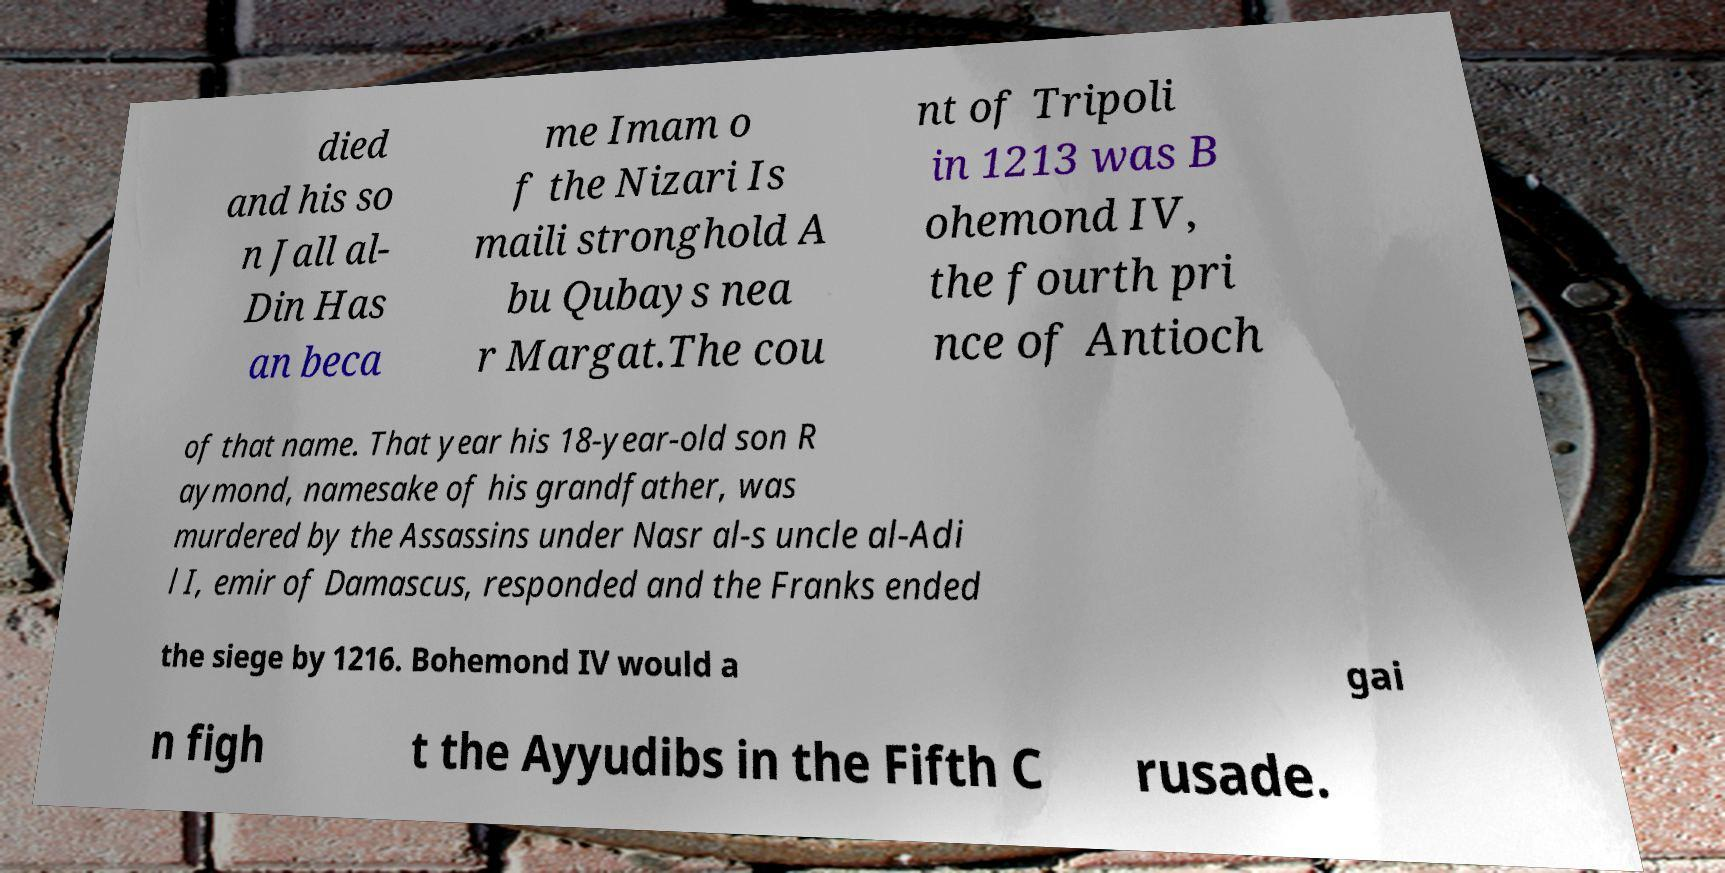Can you accurately transcribe the text from the provided image for me? died and his so n Jall al- Din Has an beca me Imam o f the Nizari Is maili stronghold A bu Qubays nea r Margat.The cou nt of Tripoli in 1213 was B ohemond IV, the fourth pri nce of Antioch of that name. That year his 18-year-old son R aymond, namesake of his grandfather, was murdered by the Assassins under Nasr al-s uncle al-Adi l I, emir of Damascus, responded and the Franks ended the siege by 1216. Bohemond IV would a gai n figh t the Ayyudibs in the Fifth C rusade. 